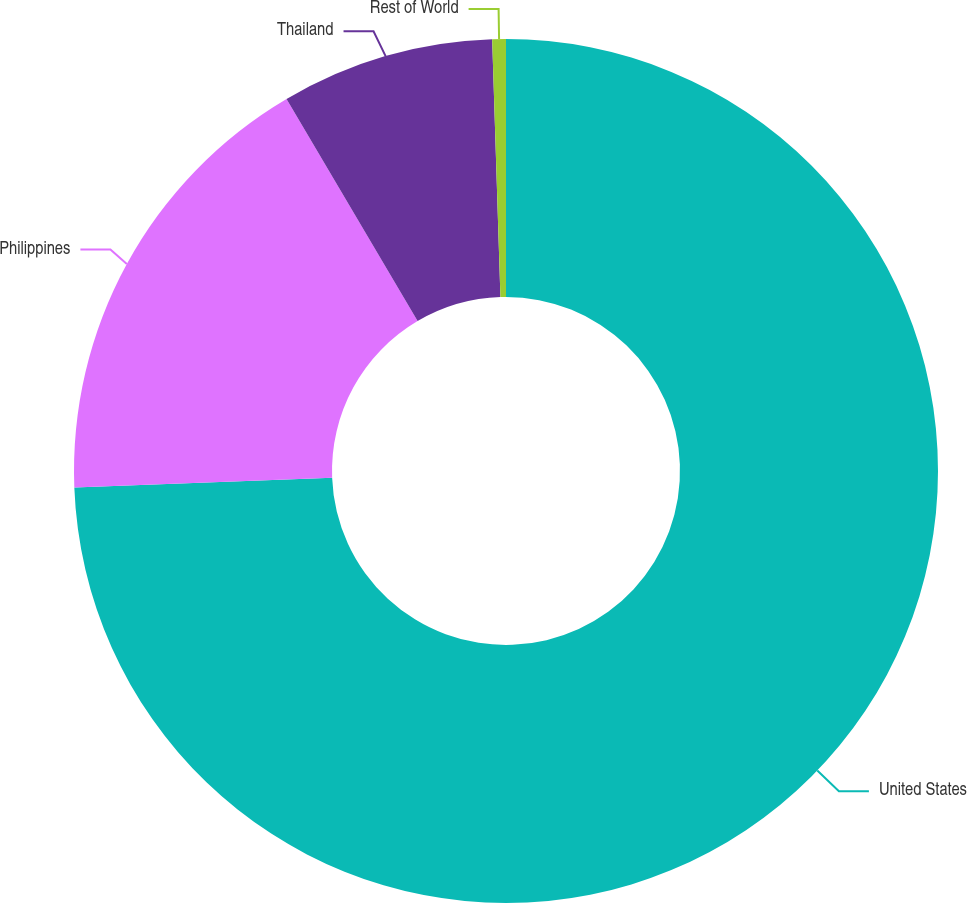Convert chart to OTSL. <chart><loc_0><loc_0><loc_500><loc_500><pie_chart><fcel>United States<fcel>Philippines<fcel>Thailand<fcel>Rest of World<nl><fcel>74.38%<fcel>17.13%<fcel>7.97%<fcel>0.51%<nl></chart> 